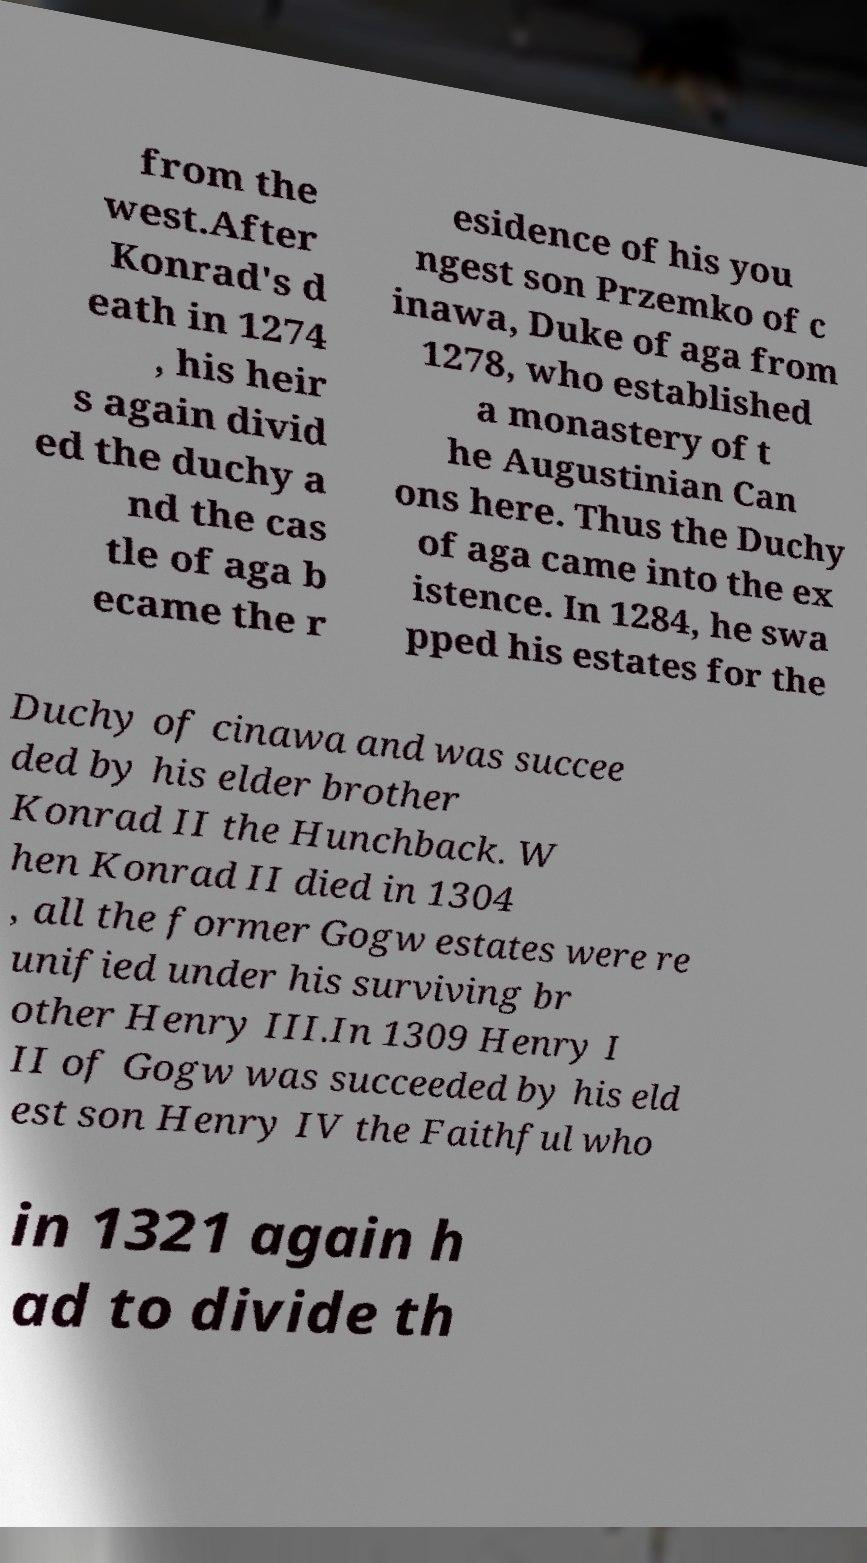There's text embedded in this image that I need extracted. Can you transcribe it verbatim? from the west.After Konrad's d eath in 1274 , his heir s again divid ed the duchy a nd the cas tle of aga b ecame the r esidence of his you ngest son Przemko of c inawa, Duke of aga from 1278, who established a monastery of t he Augustinian Can ons here. Thus the Duchy of aga came into the ex istence. In 1284, he swa pped his estates for the Duchy of cinawa and was succee ded by his elder brother Konrad II the Hunchback. W hen Konrad II died in 1304 , all the former Gogw estates were re unified under his surviving br other Henry III.In 1309 Henry I II of Gogw was succeeded by his eld est son Henry IV the Faithful who in 1321 again h ad to divide th 